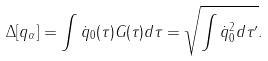Convert formula to latex. <formula><loc_0><loc_0><loc_500><loc_500>\Delta [ q _ { \alpha } ] = \int \dot { q } _ { 0 } ( \tau ) G ( \tau ) d \tau = \sqrt { \int \dot { q } _ { 0 } ^ { 2 } d \tau ^ { \prime } } .</formula> 